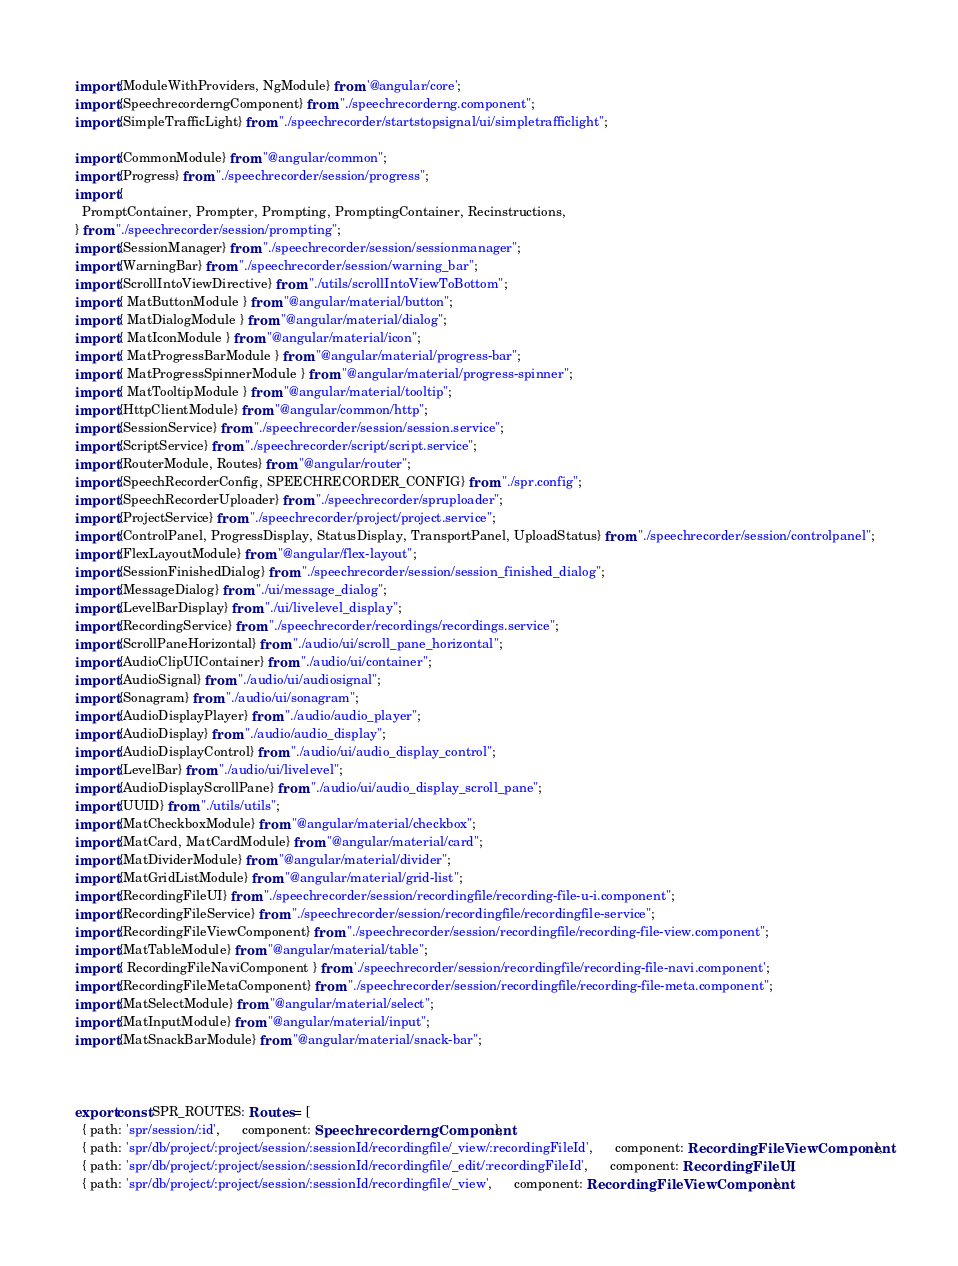<code> <loc_0><loc_0><loc_500><loc_500><_TypeScript_>import {ModuleWithProviders, NgModule} from '@angular/core';
import {SpeechrecorderngComponent} from "./speechrecorderng.component";
import {SimpleTrafficLight} from "./speechrecorder/startstopsignal/ui/simpletrafficlight";

import {CommonModule} from "@angular/common";
import {Progress} from "./speechrecorder/session/progress";
import {
  PromptContainer, Prompter, Prompting, PromptingContainer, Recinstructions,
} from "./speechrecorder/session/prompting";
import {SessionManager} from "./speechrecorder/session/sessionmanager";
import {WarningBar} from "./speechrecorder/session/warning_bar";
import {ScrollIntoViewDirective} from "./utils/scrollIntoViewToBottom";
import { MatButtonModule } from "@angular/material/button";
import { MatDialogModule } from "@angular/material/dialog";
import { MatIconModule } from "@angular/material/icon";
import { MatProgressBarModule } from "@angular/material/progress-bar";
import { MatProgressSpinnerModule } from "@angular/material/progress-spinner";
import { MatTooltipModule } from "@angular/material/tooltip";
import {HttpClientModule} from "@angular/common/http";
import {SessionService} from "./speechrecorder/session/session.service";
import {ScriptService} from "./speechrecorder/script/script.service";
import {RouterModule, Routes} from "@angular/router";
import {SpeechRecorderConfig, SPEECHRECORDER_CONFIG} from "./spr.config";
import {SpeechRecorderUploader} from "./speechrecorder/spruploader";
import {ProjectService} from "./speechrecorder/project/project.service";
import {ControlPanel, ProgressDisplay, StatusDisplay, TransportPanel, UploadStatus} from "./speechrecorder/session/controlpanel";
import {FlexLayoutModule} from "@angular/flex-layout";
import {SessionFinishedDialog} from "./speechrecorder/session/session_finished_dialog";
import {MessageDialog} from "./ui/message_dialog";
import {LevelBarDisplay} from "./ui/livelevel_display";
import {RecordingService} from "./speechrecorder/recordings/recordings.service";
import {ScrollPaneHorizontal} from "./audio/ui/scroll_pane_horizontal";
import {AudioClipUIContainer} from "./audio/ui/container";
import {AudioSignal} from "./audio/ui/audiosignal";
import {Sonagram} from "./audio/ui/sonagram";
import {AudioDisplayPlayer} from "./audio/audio_player";
import {AudioDisplay} from "./audio/audio_display";
import {AudioDisplayControl} from "./audio/ui/audio_display_control";
import {LevelBar} from "./audio/ui/livelevel";
import {AudioDisplayScrollPane} from "./audio/ui/audio_display_scroll_pane";
import {UUID} from "./utils/utils";
import {MatCheckboxModule} from "@angular/material/checkbox";
import {MatCard, MatCardModule} from "@angular/material/card";
import {MatDividerModule} from "@angular/material/divider";
import {MatGridListModule} from "@angular/material/grid-list";
import {RecordingFileUI} from "./speechrecorder/session/recordingfile/recording-file-u-i.component";
import {RecordingFileService} from "./speechrecorder/session/recordingfile/recordingfile-service";
import {RecordingFileViewComponent} from "./speechrecorder/session/recordingfile/recording-file-view.component";
import {MatTableModule} from "@angular/material/table";
import { RecordingFileNaviComponent } from './speechrecorder/session/recordingfile/recording-file-navi.component';
import {RecordingFileMetaComponent} from "./speechrecorder/session/recordingfile/recording-file-meta.component";
import {MatSelectModule} from "@angular/material/select";
import {MatInputModule} from "@angular/material/input";
import {MatSnackBarModule} from "@angular/material/snack-bar";



export const SPR_ROUTES: Routes = [
  { path: 'spr/session/:id',      component: SpeechrecorderngComponent },
  { path: 'spr/db/project/:project/session/:sessionId/recordingfile/_view/:recordingFileId',      component: RecordingFileViewComponent },
  { path: 'spr/db/project/:project/session/:sessionId/recordingfile/_edit/:recordingFileId',      component: RecordingFileUI },
  { path: 'spr/db/project/:project/session/:sessionId/recordingfile/_view',      component: RecordingFileViewComponent },</code> 